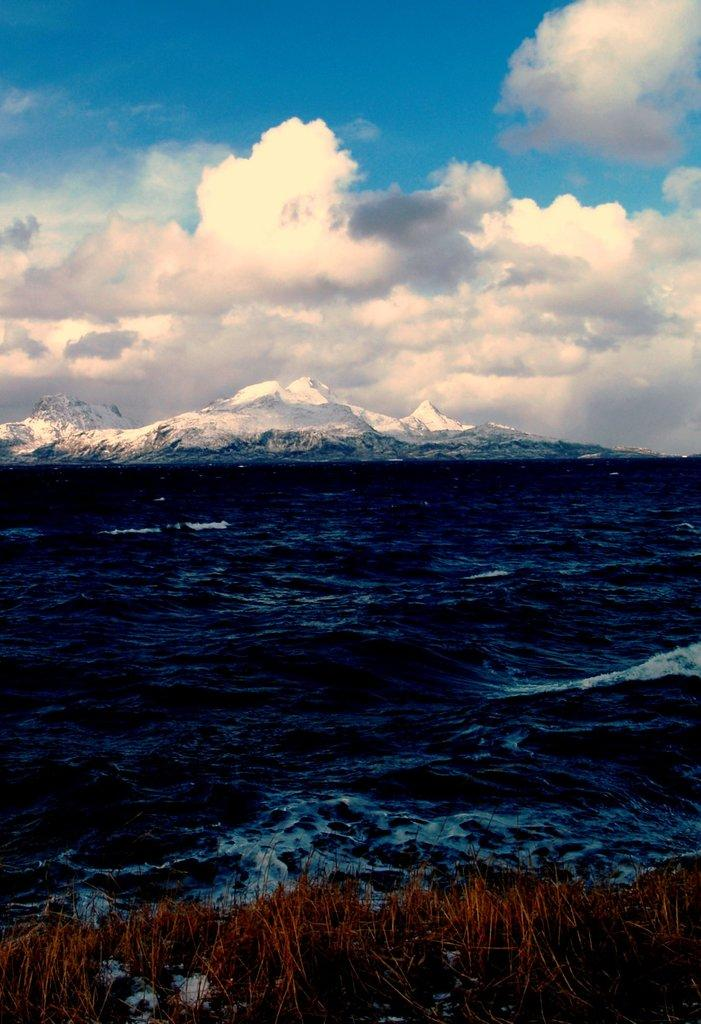What is the main subject of the image? The main subject of the image is a sea. Can you describe the sky in the background of the image? The sky in the background of the image has heavy clouds. What type of birds can be seen flying near the mailbox in the image? There are no birds or mailbox present in the image; it depicts a sea with heavy clouds in the sky. What musical instrument is being played by the person in the image? There are no people or musical instruments present in the image; it depicts a sea with heavy clouds in the sky. 